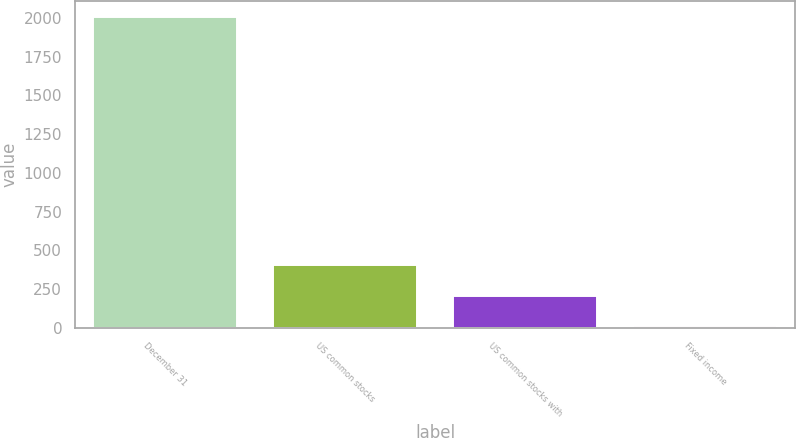<chart> <loc_0><loc_0><loc_500><loc_500><bar_chart><fcel>December 31<fcel>US common stocks<fcel>US common stocks with<fcel>Fixed income<nl><fcel>2007<fcel>407<fcel>207<fcel>7<nl></chart> 